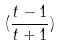Convert formula to latex. <formula><loc_0><loc_0><loc_500><loc_500>( \frac { t - 1 } { t + 1 } )</formula> 